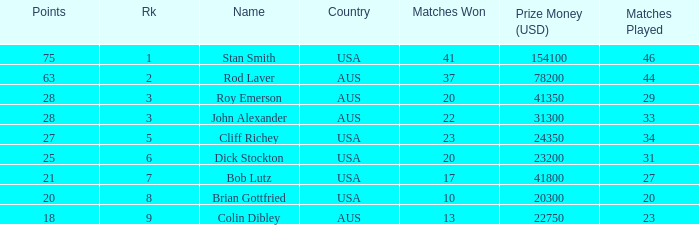How many countries had 21 points 1.0. Would you be able to parse every entry in this table? {'header': ['Points', 'Rk', 'Name', 'Country', 'Matches Won', 'Prize Money (USD)', 'Matches Played'], 'rows': [['75', '1', 'Stan Smith', 'USA', '41', '154100', '46'], ['63', '2', 'Rod Laver', 'AUS', '37', '78200', '44'], ['28', '3', 'Roy Emerson', 'AUS', '20', '41350', '29'], ['28', '3', 'John Alexander', 'AUS', '22', '31300', '33'], ['27', '5', 'Cliff Richey', 'USA', '23', '24350', '34'], ['25', '6', 'Dick Stockton', 'USA', '20', '23200', '31'], ['21', '7', 'Bob Lutz', 'USA', '17', '41800', '27'], ['20', '8', 'Brian Gottfried', 'USA', '10', '20300', '20'], ['18', '9', 'Colin Dibley', 'AUS', '13', '22750', '23']]} 